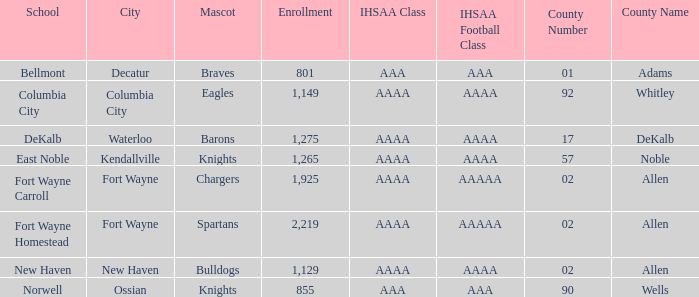What's the enrollment for Kendallville? 1265.0. 